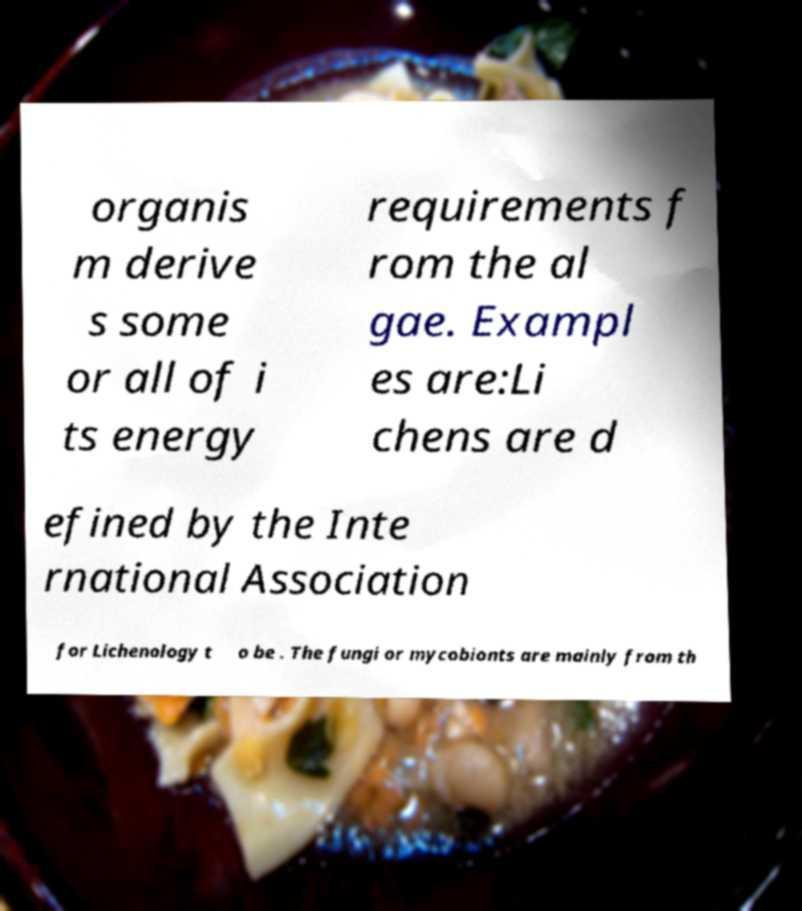Could you extract and type out the text from this image? organis m derive s some or all of i ts energy requirements f rom the al gae. Exampl es are:Li chens are d efined by the Inte rnational Association for Lichenology t o be . The fungi or mycobionts are mainly from th 